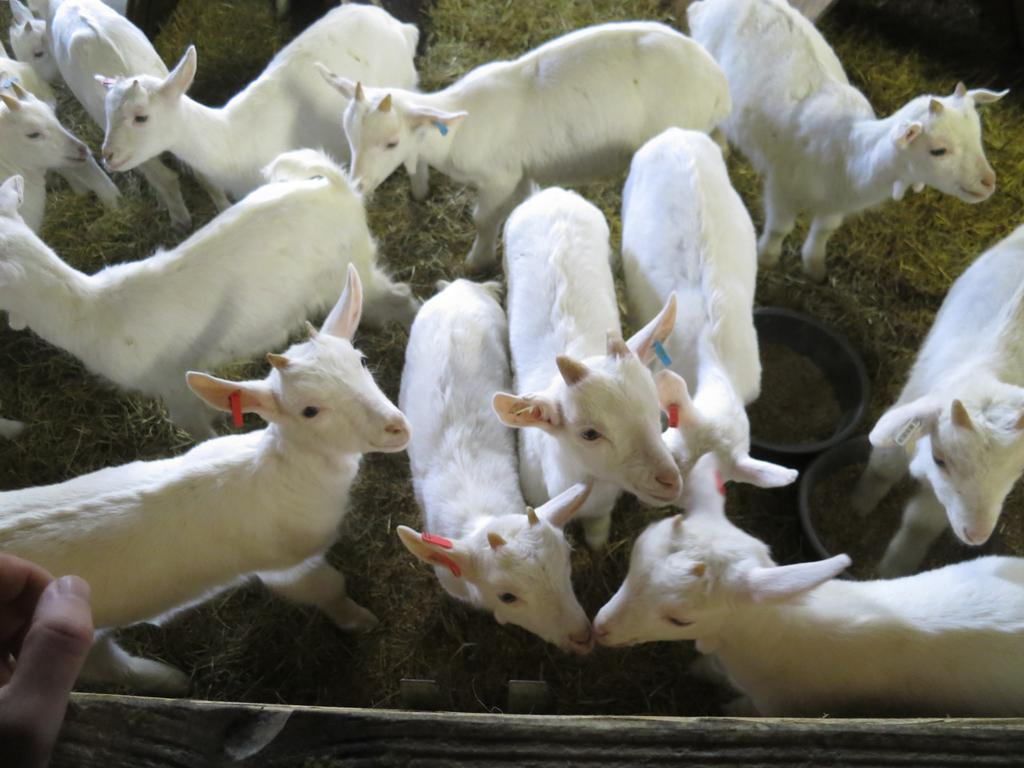What animals are present in the image? There are goats in the image. What color are the goats? The goats are white in color. What is in front of the goats? There is a fence wall in front of the goats. Can you see any human presence in the image? Yes, there is a person's hand visible in the left corner of the image. What type of view can be seen from the alley in the image? There is no alley present in the image; it features goats and a fence wall. 